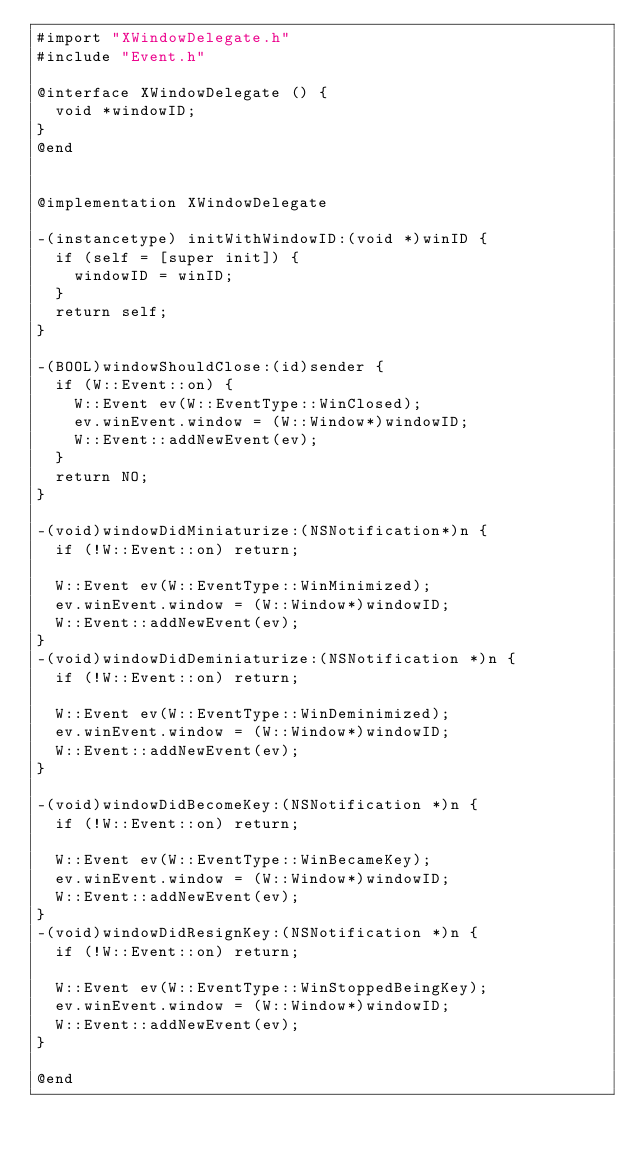Convert code to text. <code><loc_0><loc_0><loc_500><loc_500><_ObjectiveC_>#import "XWindowDelegate.h"
#include "Event.h"

@interface XWindowDelegate () {
	void *windowID;
}
@end


@implementation XWindowDelegate

-(instancetype) initWithWindowID:(void *)winID {
  if (self = [super init]) {
		windowID = winID;
  }
	return self;
}

-(BOOL)windowShouldClose:(id)sender {
	if (W::Event::on) {
		W::Event ev(W::EventType::WinClosed);
		ev.winEvent.window = (W::Window*)windowID;
		W::Event::addNewEvent(ev);
	}
	return NO;
}

-(void)windowDidMiniaturize:(NSNotification*)n {
	if (!W::Event::on) return;
	
	W::Event ev(W::EventType::WinMinimized);
	ev.winEvent.window = (W::Window*)windowID;
	W::Event::addNewEvent(ev);
}
-(void)windowDidDeminiaturize:(NSNotification *)n {
	if (!W::Event::on) return;
	
	W::Event ev(W::EventType::WinDeminimized);
	ev.winEvent.window = (W::Window*)windowID;
	W::Event::addNewEvent(ev);
}

-(void)windowDidBecomeKey:(NSNotification *)n {
	if (!W::Event::on) return;
	
	W::Event ev(W::EventType::WinBecameKey);
	ev.winEvent.window = (W::Window*)windowID;
	W::Event::addNewEvent(ev);
}
-(void)windowDidResignKey:(NSNotification *)n {
	if (!W::Event::on) return;
	
	W::Event ev(W::EventType::WinStoppedBeingKey);
	ev.winEvent.window = (W::Window*)windowID;
	W::Event::addNewEvent(ev);
}

@end
</code> 